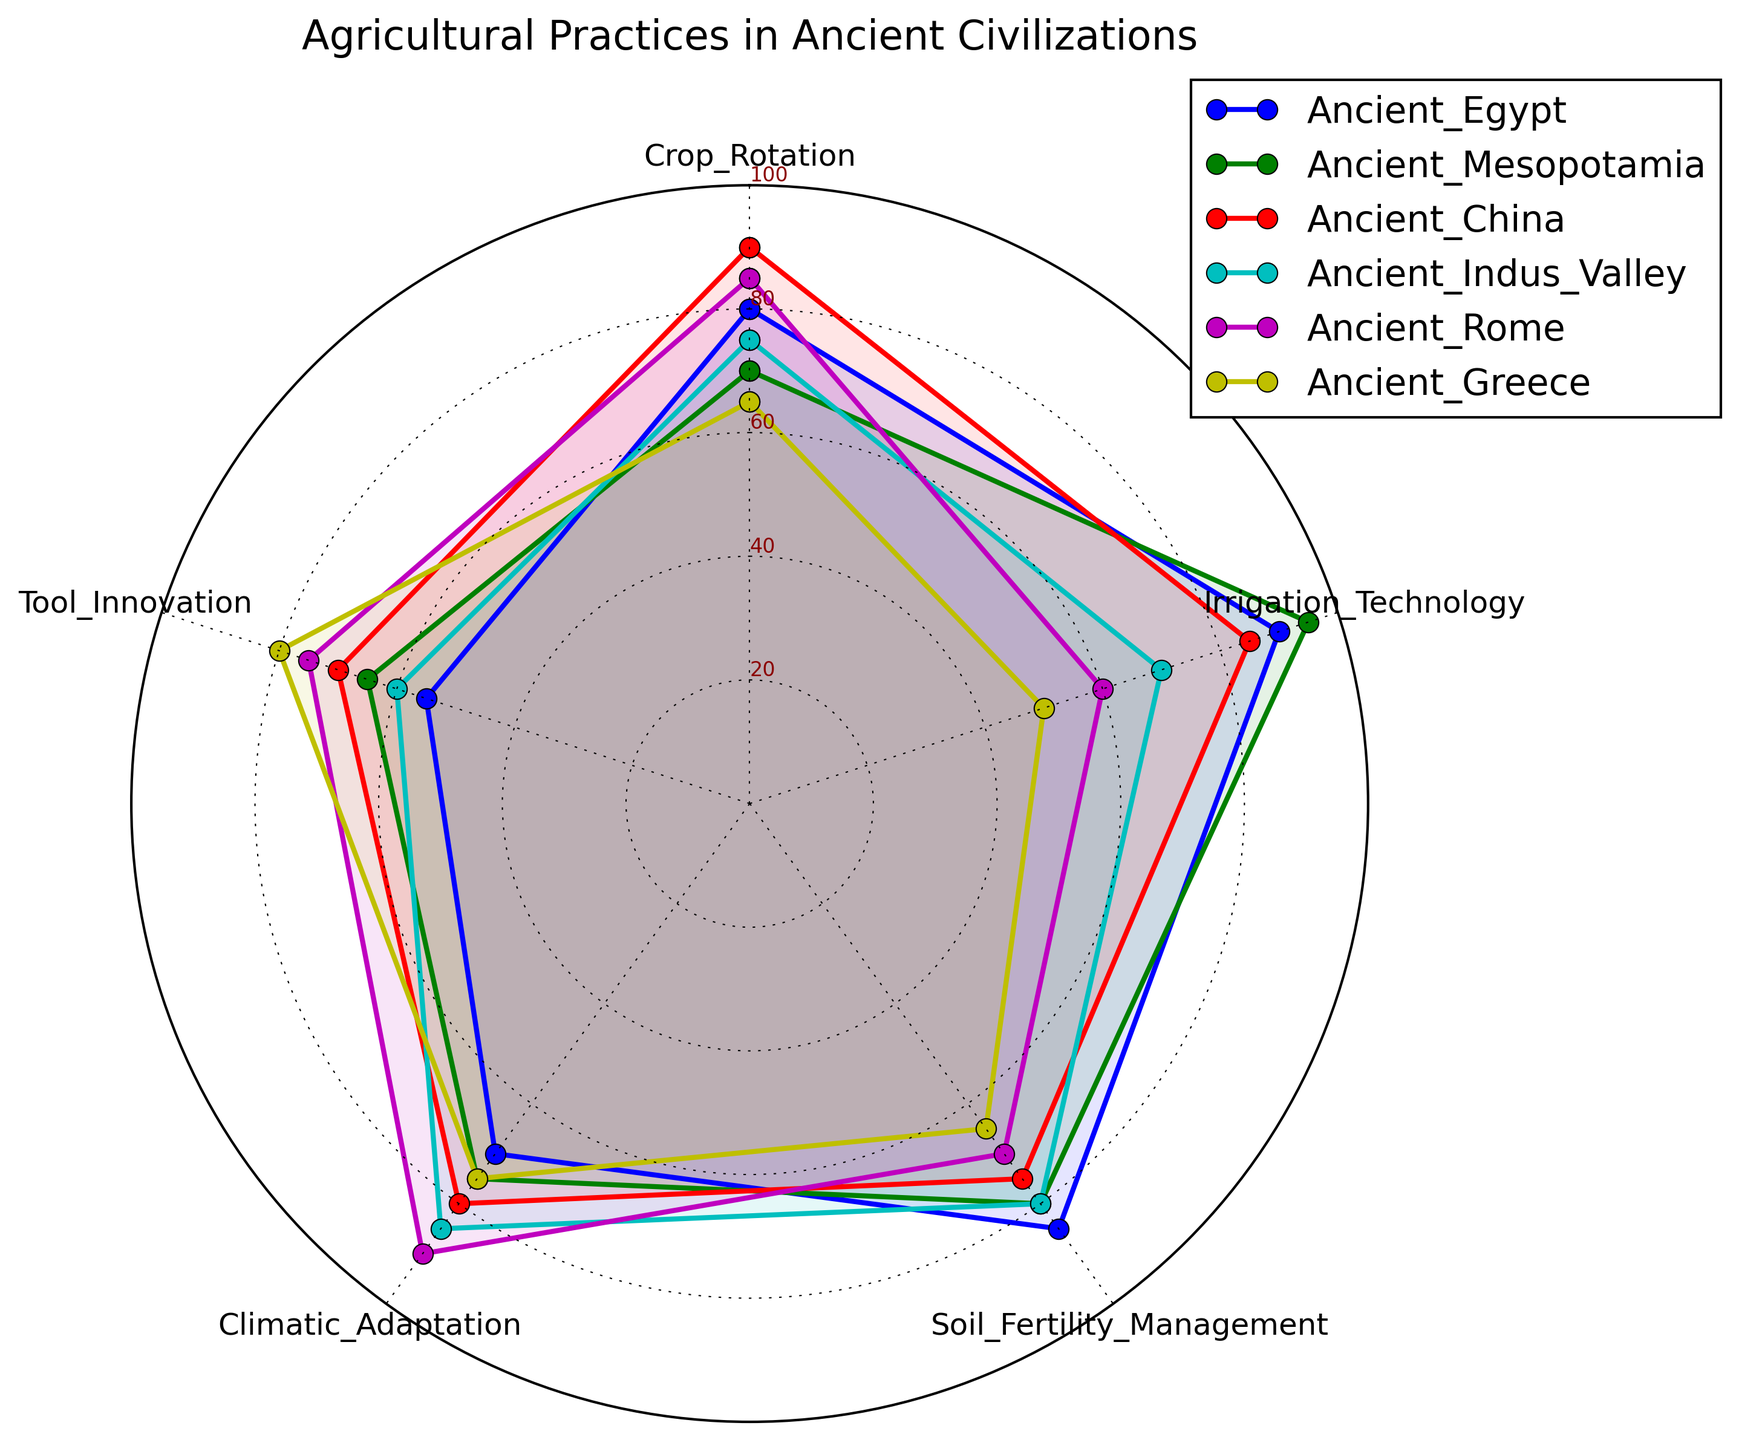Which ancient civilization has the highest score in Crop Rotation? Ancient China has the highest score in Crop Rotation, indicated as the longest radius in the Crop Rotation category.
Answer: Ancient China Which ancient civilization has the lowest score in Irrigation Technology? Ancient Greece has the lowest score in Irrigation Technology, indicated as the shortest radius in the Irrigation Technology category.
Answer: Ancient Greece How do Ancient Egypt and Ancient Mesopotamia compare in Soil Fertility Management? Ancient Egypt has a score of 85 in Soil Fertility Management, while Ancient Mesopotamia has a score of 80, indicating that Ancient Egypt has a slightly higher score in this category.
Answer: Ancient Egypt scores higher Which agricultural practice does Ancient Rome excel in the most? Ancient Rome has the highest score in Climatic Adaptation, indicated by the longest radius in this category.
Answer: Climatic Adaptation What is the average score of Ancient Indus Valley across all agricultural practices? The scores for Ancient Indus Valley are 75 (Crop Rotation) + 70 (Irrigation Technology) + 80 (Soil Fertility Management) + 85 (Climatic Adaptation) + 60 (Tool Innovation). The total is 370, and the average is 370/5 = 74.
Answer: 74 Between Ancient Egypt and Ancient Greece, which has a better score in Tool Innovation? Ancient Greece has a score of 80 in Tool Innovation, while Ancient Egypt has a score of 55, so Ancient Greece scores higher in this category.
Answer: Ancient Greece Which agricultural practice shows the greatest variation among the ancient civilizations? By visually comparing the lengths of the radii, Irrigation Technology shows the greatest variation, ranging from 50 to 95 across the civilizations.
Answer: Irrigation Technology How does Ancient Rome's performance in Crop Rotation compare with that of Ancient Mesopotamia? Ancient Rome has a score of 85 in Crop Rotation, while Ancient Mesopotamia has a score of 70, indicating Ancient Rome performs better in this category.
Answer: Ancient Rome performs better What is the total score of Ancient China across all agricultural practices? Ancient China’s scores are 90 (Crop Rotation), 85 (Irrigation Technology), 75 (Soil Fertility Management), 80 (Climatic Adaptation), and 70 (Tool Innovation). The total score is 90 + 85 + 75 + 80 + 70 = 400.
Answer: 400 Which civilization has the most balanced agricultural practices across all categories? By visually examining the uniform length of the radii, Ancient Indus Valley appears the most balanced, with all scores between 60 and 85.
Answer: Ancient Indus Valley 